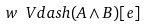Convert formula to latex. <formula><loc_0><loc_0><loc_500><loc_500>w \ V d a s h ( A \wedge B ) [ e ]</formula> 